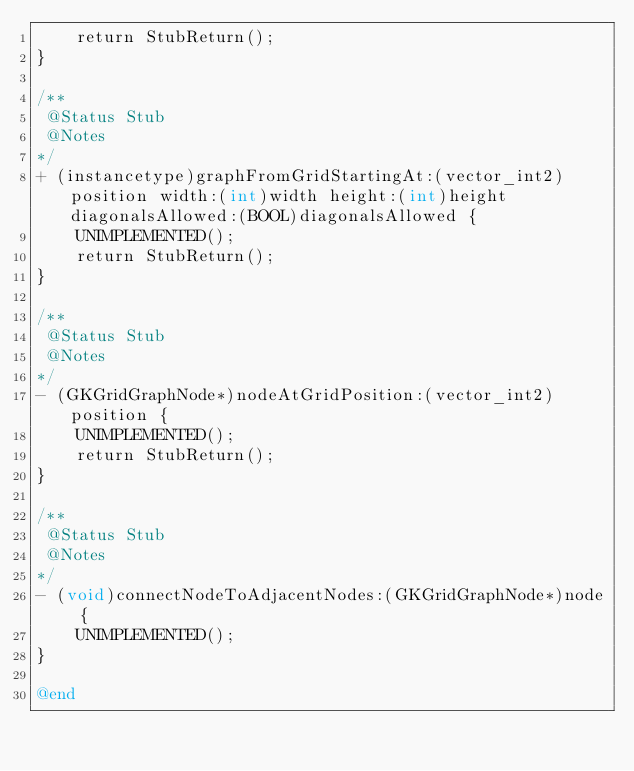<code> <loc_0><loc_0><loc_500><loc_500><_ObjectiveC_>    return StubReturn();
}

/**
 @Status Stub
 @Notes
*/
+ (instancetype)graphFromGridStartingAt:(vector_int2)position width:(int)width height:(int)height diagonalsAllowed:(BOOL)diagonalsAllowed {
    UNIMPLEMENTED();
    return StubReturn();
}

/**
 @Status Stub
 @Notes
*/
- (GKGridGraphNode*)nodeAtGridPosition:(vector_int2)position {
    UNIMPLEMENTED();
    return StubReturn();
}

/**
 @Status Stub
 @Notes
*/
- (void)connectNodeToAdjacentNodes:(GKGridGraphNode*)node {
    UNIMPLEMENTED();
}

@end
</code> 